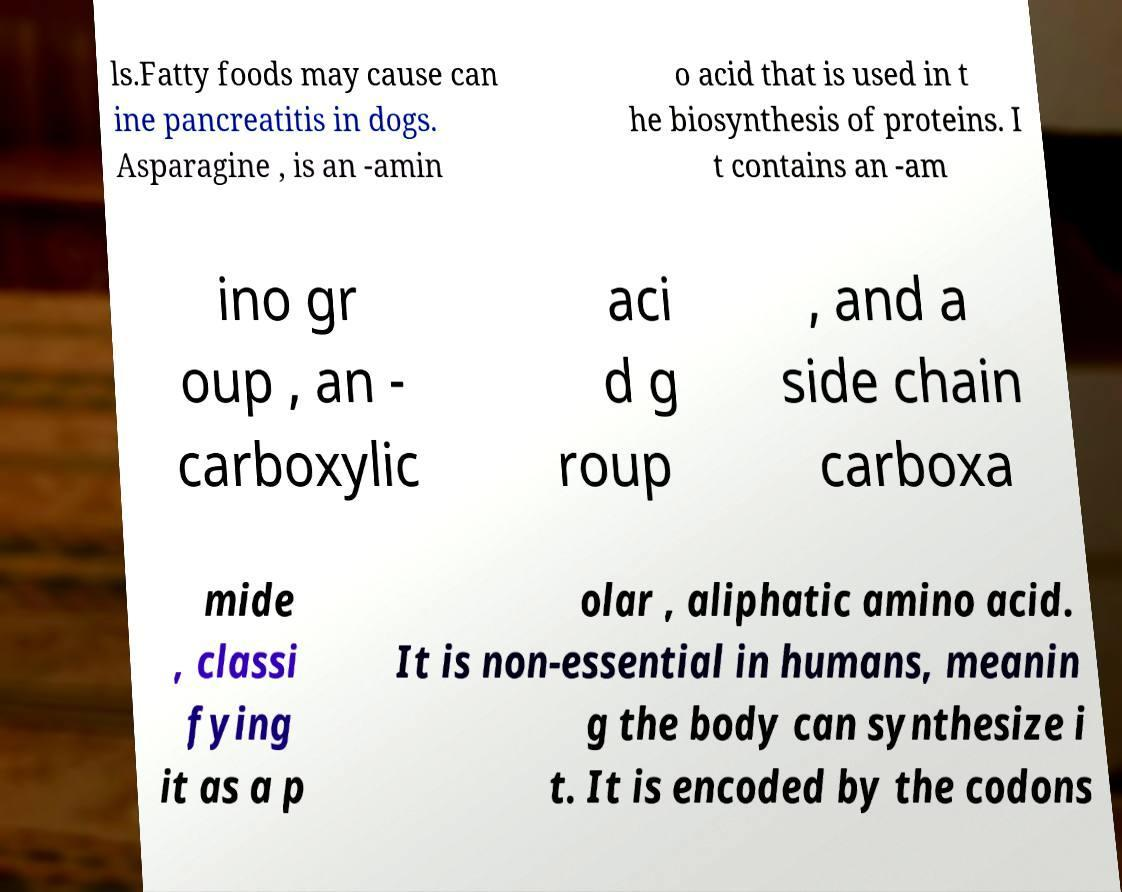Could you assist in decoding the text presented in this image and type it out clearly? ls.Fatty foods may cause can ine pancreatitis in dogs. Asparagine , is an -amin o acid that is used in t he biosynthesis of proteins. I t contains an -am ino gr oup , an - carboxylic aci d g roup , and a side chain carboxa mide , classi fying it as a p olar , aliphatic amino acid. It is non-essential in humans, meanin g the body can synthesize i t. It is encoded by the codons 